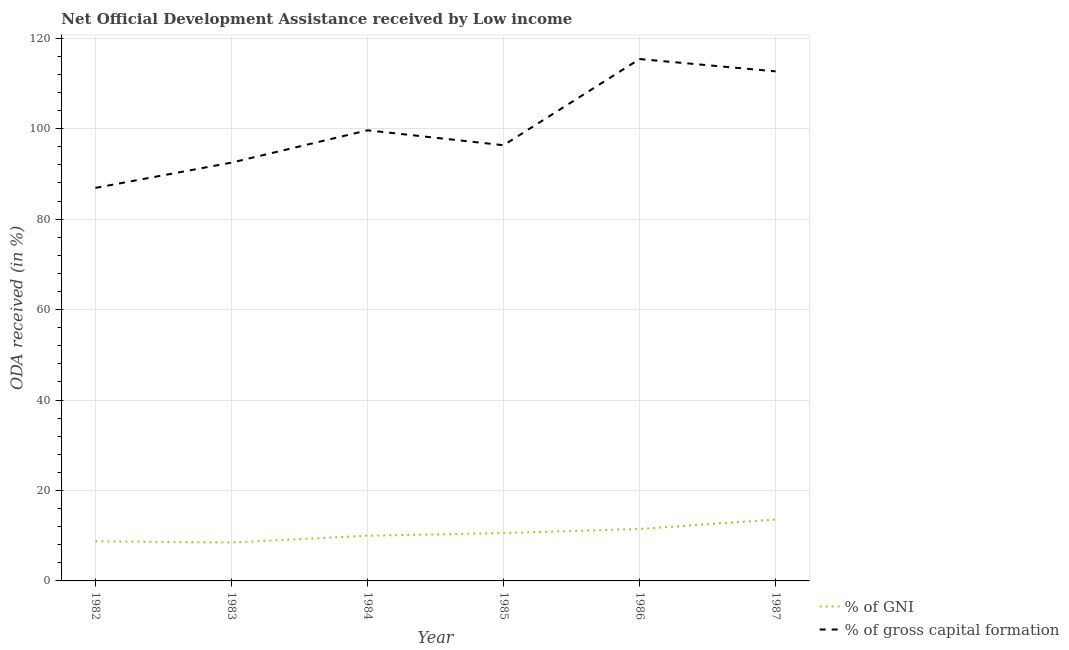How many different coloured lines are there?
Keep it short and to the point. 2. Does the line corresponding to oda received as percentage of gni intersect with the line corresponding to oda received as percentage of gross capital formation?
Provide a short and direct response. No. Is the number of lines equal to the number of legend labels?
Give a very brief answer. Yes. What is the oda received as percentage of gross capital formation in 1983?
Provide a short and direct response. 92.49. Across all years, what is the maximum oda received as percentage of gni?
Offer a terse response. 13.58. Across all years, what is the minimum oda received as percentage of gni?
Keep it short and to the point. 8.49. In which year was the oda received as percentage of gni minimum?
Offer a terse response. 1983. What is the total oda received as percentage of gni in the graph?
Your answer should be very brief. 62.91. What is the difference between the oda received as percentage of gross capital formation in 1984 and that in 1987?
Your answer should be very brief. -13.03. What is the difference between the oda received as percentage of gross capital formation in 1986 and the oda received as percentage of gni in 1987?
Offer a very short reply. 101.82. What is the average oda received as percentage of gni per year?
Keep it short and to the point. 10.49. In the year 1983, what is the difference between the oda received as percentage of gross capital formation and oda received as percentage of gni?
Your answer should be very brief. 84. In how many years, is the oda received as percentage of gni greater than 100 %?
Your answer should be compact. 0. What is the ratio of the oda received as percentage of gross capital formation in 1983 to that in 1985?
Your response must be concise. 0.96. Is the oda received as percentage of gross capital formation in 1983 less than that in 1986?
Your response must be concise. Yes. What is the difference between the highest and the second highest oda received as percentage of gross capital formation?
Keep it short and to the point. 2.72. What is the difference between the highest and the lowest oda received as percentage of gross capital formation?
Provide a short and direct response. 28.49. Does the oda received as percentage of gross capital formation monotonically increase over the years?
Provide a succinct answer. No. How many years are there in the graph?
Your response must be concise. 6. What is the difference between two consecutive major ticks on the Y-axis?
Keep it short and to the point. 20. Are the values on the major ticks of Y-axis written in scientific E-notation?
Provide a succinct answer. No. Does the graph contain any zero values?
Your answer should be very brief. No. Does the graph contain grids?
Offer a terse response. Yes. Where does the legend appear in the graph?
Your answer should be compact. Bottom right. What is the title of the graph?
Offer a very short reply. Net Official Development Assistance received by Low income. What is the label or title of the X-axis?
Offer a very short reply. Year. What is the label or title of the Y-axis?
Ensure brevity in your answer.  ODA received (in %). What is the ODA received (in %) of % of GNI in 1982?
Keep it short and to the point. 8.77. What is the ODA received (in %) in % of gross capital formation in 1982?
Offer a terse response. 86.91. What is the ODA received (in %) of % of GNI in 1983?
Your answer should be very brief. 8.49. What is the ODA received (in %) in % of gross capital formation in 1983?
Your response must be concise. 92.49. What is the ODA received (in %) of % of GNI in 1984?
Provide a succinct answer. 10. What is the ODA received (in %) in % of gross capital formation in 1984?
Offer a terse response. 99.64. What is the ODA received (in %) of % of GNI in 1985?
Provide a succinct answer. 10.58. What is the ODA received (in %) in % of gross capital formation in 1985?
Keep it short and to the point. 96.34. What is the ODA received (in %) in % of GNI in 1986?
Keep it short and to the point. 11.48. What is the ODA received (in %) in % of gross capital formation in 1986?
Keep it short and to the point. 115.4. What is the ODA received (in %) in % of GNI in 1987?
Offer a very short reply. 13.58. What is the ODA received (in %) of % of gross capital formation in 1987?
Your answer should be compact. 112.67. Across all years, what is the maximum ODA received (in %) in % of GNI?
Make the answer very short. 13.58. Across all years, what is the maximum ODA received (in %) of % of gross capital formation?
Offer a very short reply. 115.4. Across all years, what is the minimum ODA received (in %) in % of GNI?
Make the answer very short. 8.49. Across all years, what is the minimum ODA received (in %) in % of gross capital formation?
Your answer should be compact. 86.91. What is the total ODA received (in %) of % of GNI in the graph?
Your answer should be very brief. 62.91. What is the total ODA received (in %) in % of gross capital formation in the graph?
Keep it short and to the point. 603.44. What is the difference between the ODA received (in %) of % of GNI in 1982 and that in 1983?
Your response must be concise. 0.27. What is the difference between the ODA received (in %) of % of gross capital formation in 1982 and that in 1983?
Offer a very short reply. -5.59. What is the difference between the ODA received (in %) of % of GNI in 1982 and that in 1984?
Give a very brief answer. -1.23. What is the difference between the ODA received (in %) of % of gross capital formation in 1982 and that in 1984?
Your response must be concise. -12.73. What is the difference between the ODA received (in %) in % of GNI in 1982 and that in 1985?
Ensure brevity in your answer.  -1.81. What is the difference between the ODA received (in %) in % of gross capital formation in 1982 and that in 1985?
Your answer should be compact. -9.44. What is the difference between the ODA received (in %) in % of GNI in 1982 and that in 1986?
Provide a short and direct response. -2.71. What is the difference between the ODA received (in %) in % of gross capital formation in 1982 and that in 1986?
Give a very brief answer. -28.49. What is the difference between the ODA received (in %) of % of GNI in 1982 and that in 1987?
Offer a terse response. -4.81. What is the difference between the ODA received (in %) of % of gross capital formation in 1982 and that in 1987?
Make the answer very short. -25.77. What is the difference between the ODA received (in %) in % of GNI in 1983 and that in 1984?
Keep it short and to the point. -1.5. What is the difference between the ODA received (in %) in % of gross capital formation in 1983 and that in 1984?
Your answer should be very brief. -7.15. What is the difference between the ODA received (in %) of % of GNI in 1983 and that in 1985?
Make the answer very short. -2.09. What is the difference between the ODA received (in %) of % of gross capital formation in 1983 and that in 1985?
Your response must be concise. -3.85. What is the difference between the ODA received (in %) in % of GNI in 1983 and that in 1986?
Your answer should be compact. -2.99. What is the difference between the ODA received (in %) of % of gross capital formation in 1983 and that in 1986?
Your answer should be compact. -22.9. What is the difference between the ODA received (in %) in % of GNI in 1983 and that in 1987?
Make the answer very short. -5.09. What is the difference between the ODA received (in %) of % of gross capital formation in 1983 and that in 1987?
Your answer should be very brief. -20.18. What is the difference between the ODA received (in %) in % of GNI in 1984 and that in 1985?
Offer a terse response. -0.58. What is the difference between the ODA received (in %) of % of gross capital formation in 1984 and that in 1985?
Keep it short and to the point. 3.3. What is the difference between the ODA received (in %) in % of GNI in 1984 and that in 1986?
Provide a short and direct response. -1.49. What is the difference between the ODA received (in %) in % of gross capital formation in 1984 and that in 1986?
Your answer should be compact. -15.76. What is the difference between the ODA received (in %) in % of GNI in 1984 and that in 1987?
Keep it short and to the point. -3.58. What is the difference between the ODA received (in %) of % of gross capital formation in 1984 and that in 1987?
Offer a terse response. -13.03. What is the difference between the ODA received (in %) in % of GNI in 1985 and that in 1986?
Provide a succinct answer. -0.9. What is the difference between the ODA received (in %) in % of gross capital formation in 1985 and that in 1986?
Give a very brief answer. -19.05. What is the difference between the ODA received (in %) of % of GNI in 1985 and that in 1987?
Make the answer very short. -3. What is the difference between the ODA received (in %) of % of gross capital formation in 1985 and that in 1987?
Provide a succinct answer. -16.33. What is the difference between the ODA received (in %) of % of GNI in 1986 and that in 1987?
Ensure brevity in your answer.  -2.1. What is the difference between the ODA received (in %) in % of gross capital formation in 1986 and that in 1987?
Provide a succinct answer. 2.72. What is the difference between the ODA received (in %) of % of GNI in 1982 and the ODA received (in %) of % of gross capital formation in 1983?
Provide a succinct answer. -83.72. What is the difference between the ODA received (in %) of % of GNI in 1982 and the ODA received (in %) of % of gross capital formation in 1984?
Make the answer very short. -90.87. What is the difference between the ODA received (in %) of % of GNI in 1982 and the ODA received (in %) of % of gross capital formation in 1985?
Your answer should be compact. -87.57. What is the difference between the ODA received (in %) of % of GNI in 1982 and the ODA received (in %) of % of gross capital formation in 1986?
Keep it short and to the point. -106.63. What is the difference between the ODA received (in %) of % of GNI in 1982 and the ODA received (in %) of % of gross capital formation in 1987?
Your answer should be compact. -103.9. What is the difference between the ODA received (in %) in % of GNI in 1983 and the ODA received (in %) in % of gross capital formation in 1984?
Your answer should be compact. -91.14. What is the difference between the ODA received (in %) in % of GNI in 1983 and the ODA received (in %) in % of gross capital formation in 1985?
Your response must be concise. -87.85. What is the difference between the ODA received (in %) in % of GNI in 1983 and the ODA received (in %) in % of gross capital formation in 1986?
Offer a terse response. -106.9. What is the difference between the ODA received (in %) of % of GNI in 1983 and the ODA received (in %) of % of gross capital formation in 1987?
Provide a succinct answer. -104.18. What is the difference between the ODA received (in %) in % of GNI in 1984 and the ODA received (in %) in % of gross capital formation in 1985?
Keep it short and to the point. -86.34. What is the difference between the ODA received (in %) of % of GNI in 1984 and the ODA received (in %) of % of gross capital formation in 1986?
Make the answer very short. -105.4. What is the difference between the ODA received (in %) of % of GNI in 1984 and the ODA received (in %) of % of gross capital formation in 1987?
Provide a short and direct response. -102.67. What is the difference between the ODA received (in %) in % of GNI in 1985 and the ODA received (in %) in % of gross capital formation in 1986?
Make the answer very short. -104.81. What is the difference between the ODA received (in %) of % of GNI in 1985 and the ODA received (in %) of % of gross capital formation in 1987?
Ensure brevity in your answer.  -102.09. What is the difference between the ODA received (in %) of % of GNI in 1986 and the ODA received (in %) of % of gross capital formation in 1987?
Make the answer very short. -101.19. What is the average ODA received (in %) of % of GNI per year?
Provide a succinct answer. 10.49. What is the average ODA received (in %) of % of gross capital formation per year?
Give a very brief answer. 100.57. In the year 1982, what is the difference between the ODA received (in %) in % of GNI and ODA received (in %) in % of gross capital formation?
Keep it short and to the point. -78.14. In the year 1983, what is the difference between the ODA received (in %) in % of GNI and ODA received (in %) in % of gross capital formation?
Your answer should be very brief. -84. In the year 1984, what is the difference between the ODA received (in %) in % of GNI and ODA received (in %) in % of gross capital formation?
Give a very brief answer. -89.64. In the year 1985, what is the difference between the ODA received (in %) in % of GNI and ODA received (in %) in % of gross capital formation?
Provide a succinct answer. -85.76. In the year 1986, what is the difference between the ODA received (in %) in % of GNI and ODA received (in %) in % of gross capital formation?
Your answer should be very brief. -103.91. In the year 1987, what is the difference between the ODA received (in %) of % of GNI and ODA received (in %) of % of gross capital formation?
Offer a very short reply. -99.09. What is the ratio of the ODA received (in %) of % of GNI in 1982 to that in 1983?
Your answer should be very brief. 1.03. What is the ratio of the ODA received (in %) in % of gross capital formation in 1982 to that in 1983?
Provide a short and direct response. 0.94. What is the ratio of the ODA received (in %) in % of GNI in 1982 to that in 1984?
Make the answer very short. 0.88. What is the ratio of the ODA received (in %) in % of gross capital formation in 1982 to that in 1984?
Your answer should be compact. 0.87. What is the ratio of the ODA received (in %) in % of GNI in 1982 to that in 1985?
Keep it short and to the point. 0.83. What is the ratio of the ODA received (in %) of % of gross capital formation in 1982 to that in 1985?
Offer a very short reply. 0.9. What is the ratio of the ODA received (in %) in % of GNI in 1982 to that in 1986?
Provide a short and direct response. 0.76. What is the ratio of the ODA received (in %) in % of gross capital formation in 1982 to that in 1986?
Your answer should be compact. 0.75. What is the ratio of the ODA received (in %) in % of GNI in 1982 to that in 1987?
Make the answer very short. 0.65. What is the ratio of the ODA received (in %) in % of gross capital formation in 1982 to that in 1987?
Offer a terse response. 0.77. What is the ratio of the ODA received (in %) of % of GNI in 1983 to that in 1984?
Your response must be concise. 0.85. What is the ratio of the ODA received (in %) of % of gross capital formation in 1983 to that in 1984?
Your answer should be very brief. 0.93. What is the ratio of the ODA received (in %) in % of GNI in 1983 to that in 1985?
Your answer should be compact. 0.8. What is the ratio of the ODA received (in %) in % of GNI in 1983 to that in 1986?
Offer a terse response. 0.74. What is the ratio of the ODA received (in %) of % of gross capital formation in 1983 to that in 1986?
Give a very brief answer. 0.8. What is the ratio of the ODA received (in %) of % of GNI in 1983 to that in 1987?
Your response must be concise. 0.63. What is the ratio of the ODA received (in %) in % of gross capital formation in 1983 to that in 1987?
Your answer should be compact. 0.82. What is the ratio of the ODA received (in %) of % of GNI in 1984 to that in 1985?
Make the answer very short. 0.94. What is the ratio of the ODA received (in %) in % of gross capital formation in 1984 to that in 1985?
Keep it short and to the point. 1.03. What is the ratio of the ODA received (in %) in % of GNI in 1984 to that in 1986?
Your answer should be very brief. 0.87. What is the ratio of the ODA received (in %) of % of gross capital formation in 1984 to that in 1986?
Keep it short and to the point. 0.86. What is the ratio of the ODA received (in %) of % of GNI in 1984 to that in 1987?
Offer a terse response. 0.74. What is the ratio of the ODA received (in %) of % of gross capital formation in 1984 to that in 1987?
Offer a very short reply. 0.88. What is the ratio of the ODA received (in %) in % of GNI in 1985 to that in 1986?
Provide a short and direct response. 0.92. What is the ratio of the ODA received (in %) of % of gross capital formation in 1985 to that in 1986?
Offer a very short reply. 0.83. What is the ratio of the ODA received (in %) of % of GNI in 1985 to that in 1987?
Give a very brief answer. 0.78. What is the ratio of the ODA received (in %) in % of gross capital formation in 1985 to that in 1987?
Ensure brevity in your answer.  0.86. What is the ratio of the ODA received (in %) in % of GNI in 1986 to that in 1987?
Provide a succinct answer. 0.85. What is the ratio of the ODA received (in %) of % of gross capital formation in 1986 to that in 1987?
Offer a terse response. 1.02. What is the difference between the highest and the second highest ODA received (in %) in % of GNI?
Offer a terse response. 2.1. What is the difference between the highest and the second highest ODA received (in %) of % of gross capital formation?
Offer a very short reply. 2.72. What is the difference between the highest and the lowest ODA received (in %) in % of GNI?
Give a very brief answer. 5.09. What is the difference between the highest and the lowest ODA received (in %) of % of gross capital formation?
Keep it short and to the point. 28.49. 